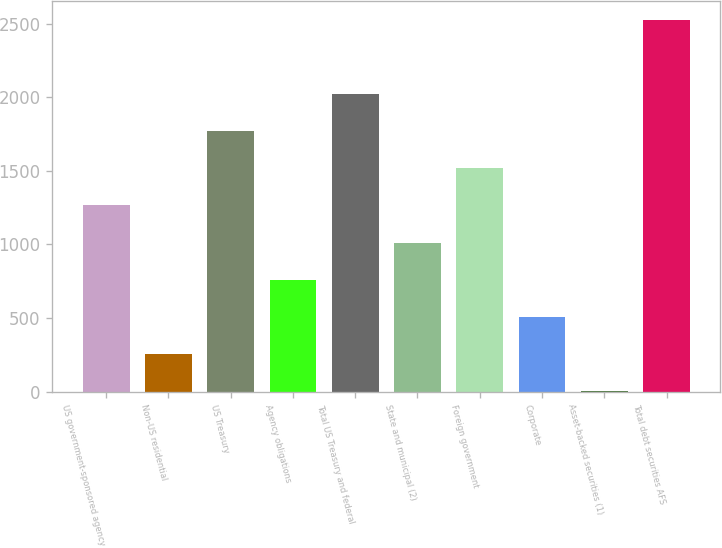Convert chart. <chart><loc_0><loc_0><loc_500><loc_500><bar_chart><fcel>US government-sponsored agency<fcel>Non-US residential<fcel>US Treasury<fcel>Agency obligations<fcel>Total US Treasury and federal<fcel>State and municipal (2)<fcel>Foreign government<fcel>Corporate<fcel>Asset-backed securities (1)<fcel>Total debt securities AFS<nl><fcel>1264.5<fcel>254.5<fcel>1769.5<fcel>759.5<fcel>2022<fcel>1012<fcel>1517<fcel>507<fcel>2<fcel>2526<nl></chart> 